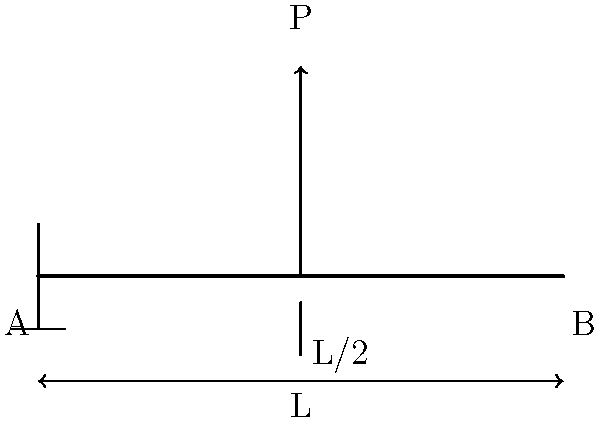A simply supported beam of length L is subjected to a point load P at its midpoint. The beam has a rectangular cross-section with width b and height h. Calculate the maximum bending stress in the beam. Express your answer in terms of P, L, b, and h. To calculate the maximum bending stress in the beam, we'll follow these steps:

1. Determine the maximum bending moment:
   The maximum bending moment occurs at the midpoint of the beam.
   $$M_{max} = \frac{PL}{4}$$

2. Calculate the moment of inertia for a rectangular cross-section:
   $$I = \frac{bh^3}{12}$$

3. Find the distance from the neutral axis to the extreme fiber:
   $$y = \frac{h}{2}$$

4. Apply the flexure formula to calculate the maximum bending stress:
   $$\sigma_{max} = \frac{My}{I}$$

5. Substitute the values:
   $$\sigma_{max} = \frac{(\frac{PL}{4})(\frac{h}{2})}{\frac{bh^3}{12}}$$

6. Simplify the expression:
   $$\sigma_{max} = \frac{3PL}{2bh^2}$$

This final expression represents the maximum bending stress in the beam in terms of P, L, b, and h.
Answer: $$\sigma_{max} = \frac{3PL}{2bh^2}$$ 